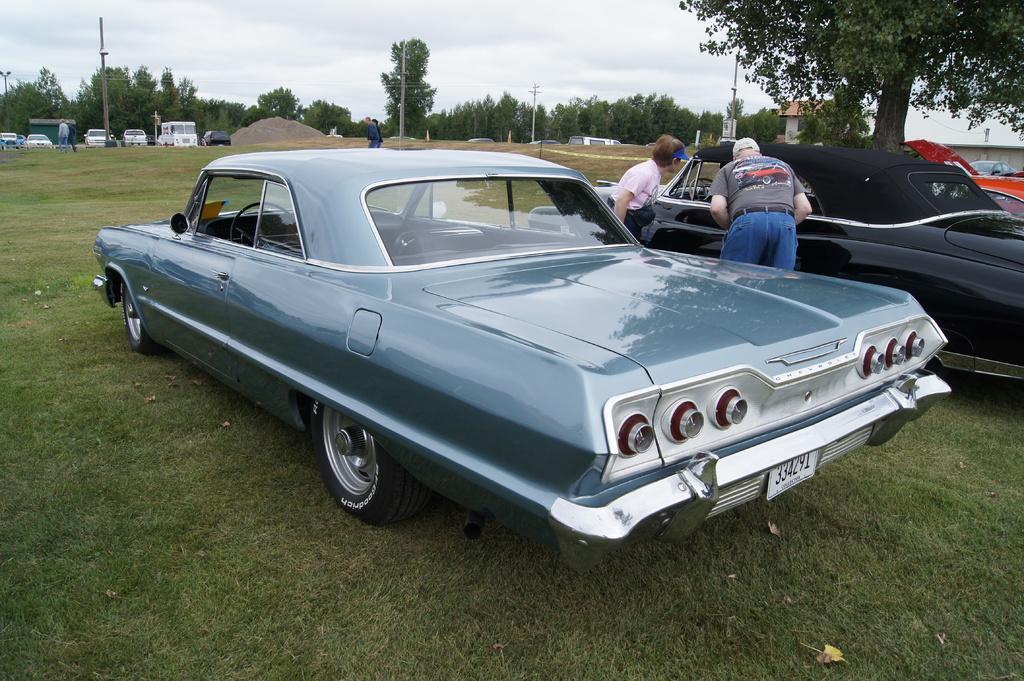In one or two sentences, can you explain what this image depicts? In this image I can see the cars on the ground. To the side of the black car I can see two people with different color dresses. In the background I can see few more people, vehicles, poles, many trees and the sky. 